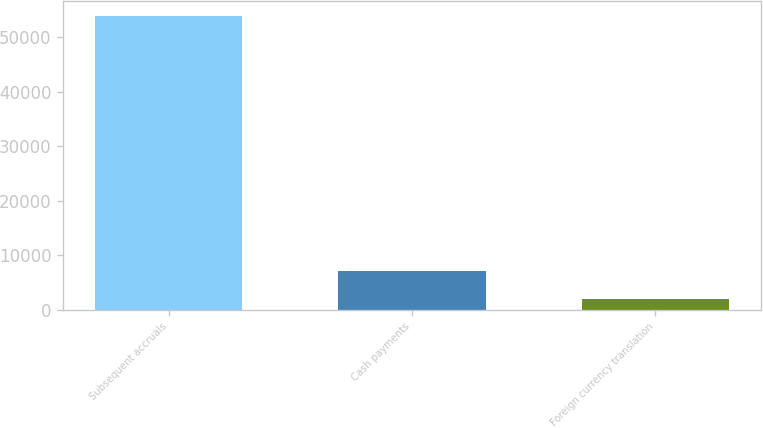<chart> <loc_0><loc_0><loc_500><loc_500><bar_chart><fcel>Subsequent accruals<fcel>Cash payments<fcel>Foreign currency translation<nl><fcel>53992<fcel>7212.7<fcel>2015<nl></chart> 